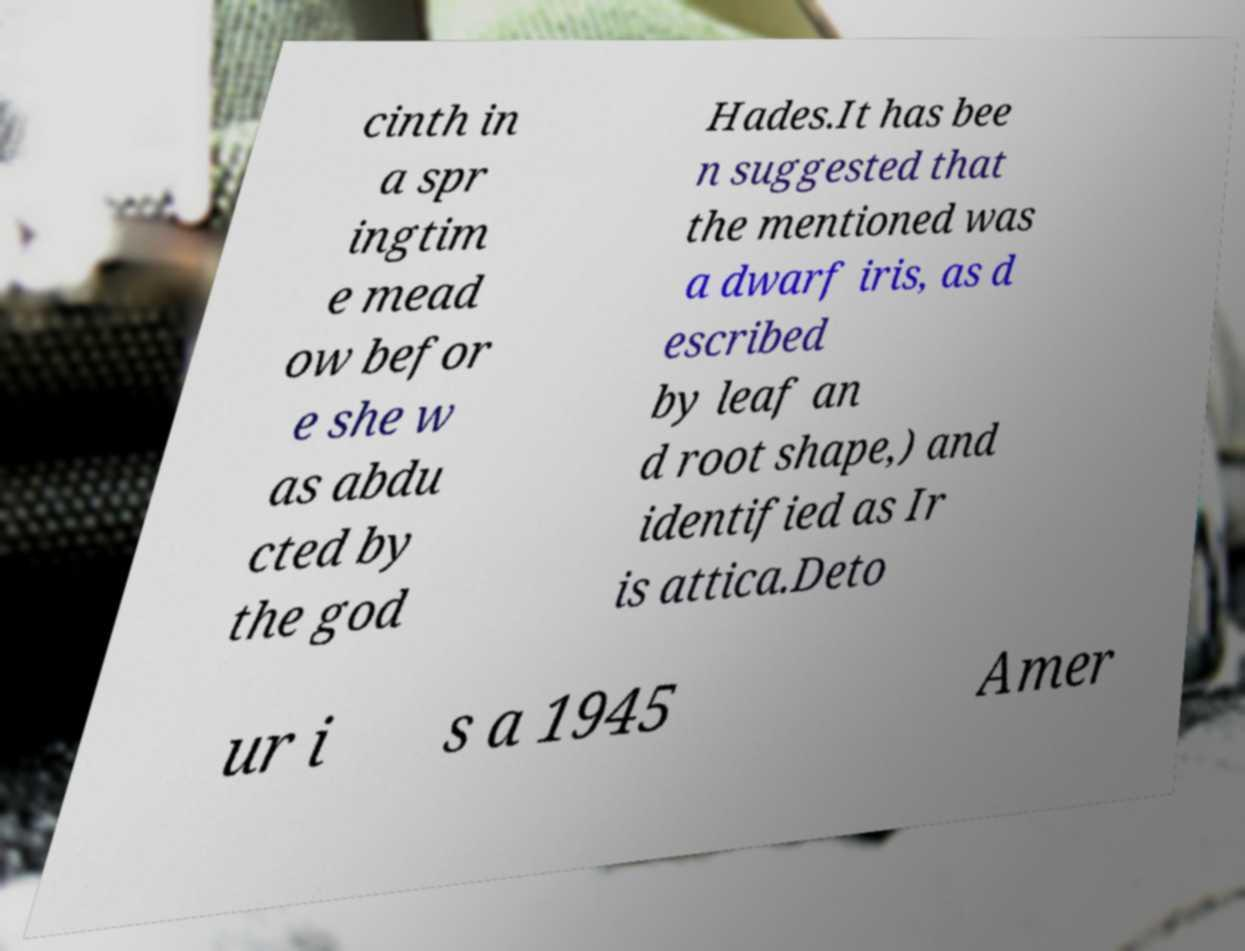What messages or text are displayed in this image? I need them in a readable, typed format. cinth in a spr ingtim e mead ow befor e she w as abdu cted by the god Hades.It has bee n suggested that the mentioned was a dwarf iris, as d escribed by leaf an d root shape,) and identified as Ir is attica.Deto ur i s a 1945 Amer 